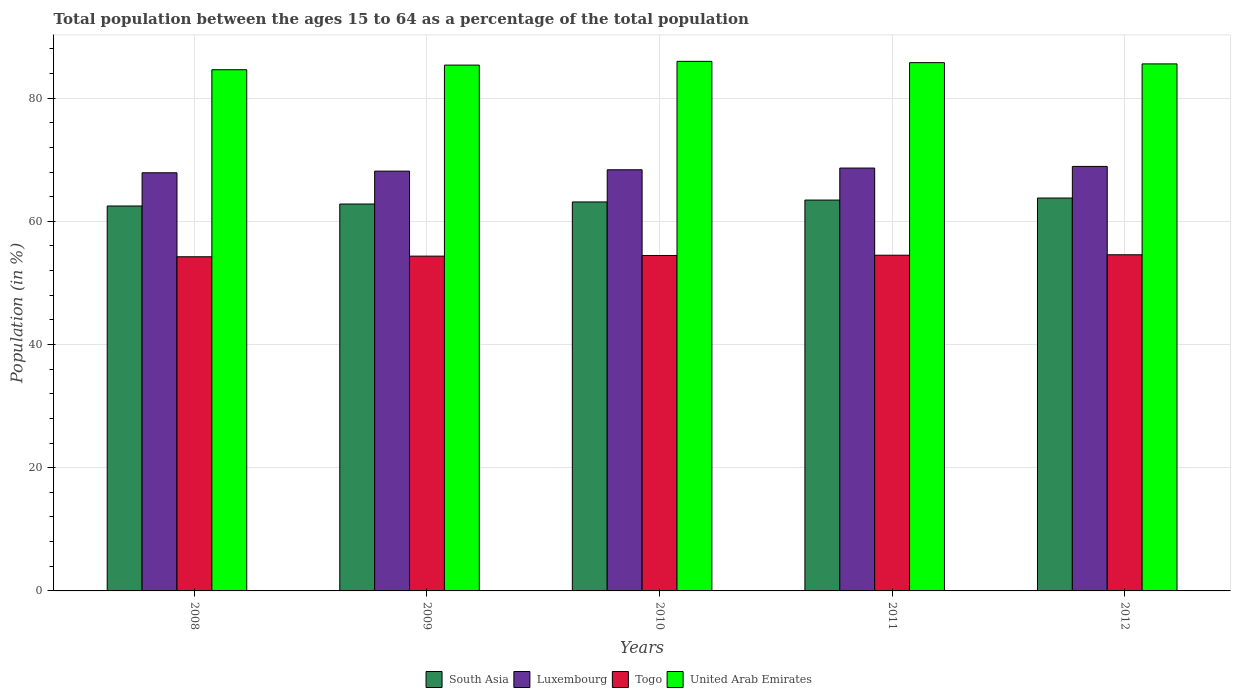Are the number of bars per tick equal to the number of legend labels?
Provide a succinct answer. Yes. How many bars are there on the 3rd tick from the left?
Your response must be concise. 4. How many bars are there on the 4th tick from the right?
Ensure brevity in your answer.  4. What is the label of the 3rd group of bars from the left?
Offer a terse response. 2010. What is the percentage of the population ages 15 to 64 in United Arab Emirates in 2008?
Offer a terse response. 84.6. Across all years, what is the maximum percentage of the population ages 15 to 64 in United Arab Emirates?
Your answer should be compact. 85.96. Across all years, what is the minimum percentage of the population ages 15 to 64 in Togo?
Make the answer very short. 54.24. What is the total percentage of the population ages 15 to 64 in Togo in the graph?
Your response must be concise. 272.1. What is the difference between the percentage of the population ages 15 to 64 in Togo in 2011 and that in 2012?
Your answer should be compact. -0.07. What is the difference between the percentage of the population ages 15 to 64 in South Asia in 2008 and the percentage of the population ages 15 to 64 in Luxembourg in 2009?
Make the answer very short. -5.66. What is the average percentage of the population ages 15 to 64 in Luxembourg per year?
Ensure brevity in your answer.  68.39. In the year 2010, what is the difference between the percentage of the population ages 15 to 64 in United Arab Emirates and percentage of the population ages 15 to 64 in South Asia?
Give a very brief answer. 22.82. In how many years, is the percentage of the population ages 15 to 64 in United Arab Emirates greater than 76?
Give a very brief answer. 5. What is the ratio of the percentage of the population ages 15 to 64 in Togo in 2008 to that in 2010?
Give a very brief answer. 1. Is the percentage of the population ages 15 to 64 in Luxembourg in 2008 less than that in 2010?
Provide a succinct answer. Yes. What is the difference between the highest and the second highest percentage of the population ages 15 to 64 in United Arab Emirates?
Offer a terse response. 0.21. What is the difference between the highest and the lowest percentage of the population ages 15 to 64 in United Arab Emirates?
Make the answer very short. 1.36. In how many years, is the percentage of the population ages 15 to 64 in South Asia greater than the average percentage of the population ages 15 to 64 in South Asia taken over all years?
Keep it short and to the point. 3. Is the sum of the percentage of the population ages 15 to 64 in South Asia in 2009 and 2010 greater than the maximum percentage of the population ages 15 to 64 in United Arab Emirates across all years?
Offer a very short reply. Yes. What does the 4th bar from the left in 2009 represents?
Ensure brevity in your answer.  United Arab Emirates. What does the 3rd bar from the right in 2009 represents?
Give a very brief answer. Luxembourg. How many bars are there?
Offer a very short reply. 20. What is the difference between two consecutive major ticks on the Y-axis?
Give a very brief answer. 20. Are the values on the major ticks of Y-axis written in scientific E-notation?
Provide a short and direct response. No. What is the title of the graph?
Provide a succinct answer. Total population between the ages 15 to 64 as a percentage of the total population. What is the Population (in %) in South Asia in 2008?
Your answer should be very brief. 62.49. What is the Population (in %) of Luxembourg in 2008?
Give a very brief answer. 67.88. What is the Population (in %) of Togo in 2008?
Make the answer very short. 54.24. What is the Population (in %) in United Arab Emirates in 2008?
Your response must be concise. 84.6. What is the Population (in %) of South Asia in 2009?
Give a very brief answer. 62.8. What is the Population (in %) of Luxembourg in 2009?
Make the answer very short. 68.14. What is the Population (in %) of Togo in 2009?
Keep it short and to the point. 54.34. What is the Population (in %) of United Arab Emirates in 2009?
Your answer should be compact. 85.35. What is the Population (in %) in South Asia in 2010?
Your answer should be very brief. 63.14. What is the Population (in %) of Luxembourg in 2010?
Make the answer very short. 68.36. What is the Population (in %) in Togo in 2010?
Your response must be concise. 54.45. What is the Population (in %) in United Arab Emirates in 2010?
Keep it short and to the point. 85.96. What is the Population (in %) of South Asia in 2011?
Your response must be concise. 63.45. What is the Population (in %) in Luxembourg in 2011?
Provide a short and direct response. 68.64. What is the Population (in %) in Togo in 2011?
Make the answer very short. 54.49. What is the Population (in %) of United Arab Emirates in 2011?
Your response must be concise. 85.75. What is the Population (in %) of South Asia in 2012?
Offer a very short reply. 63.78. What is the Population (in %) of Luxembourg in 2012?
Provide a short and direct response. 68.91. What is the Population (in %) in Togo in 2012?
Your answer should be compact. 54.57. What is the Population (in %) in United Arab Emirates in 2012?
Provide a succinct answer. 85.55. Across all years, what is the maximum Population (in %) in South Asia?
Make the answer very short. 63.78. Across all years, what is the maximum Population (in %) of Luxembourg?
Offer a very short reply. 68.91. Across all years, what is the maximum Population (in %) of Togo?
Offer a terse response. 54.57. Across all years, what is the maximum Population (in %) of United Arab Emirates?
Ensure brevity in your answer.  85.96. Across all years, what is the minimum Population (in %) in South Asia?
Your answer should be compact. 62.49. Across all years, what is the minimum Population (in %) in Luxembourg?
Offer a terse response. 67.88. Across all years, what is the minimum Population (in %) in Togo?
Make the answer very short. 54.24. Across all years, what is the minimum Population (in %) of United Arab Emirates?
Give a very brief answer. 84.6. What is the total Population (in %) of South Asia in the graph?
Provide a succinct answer. 315.65. What is the total Population (in %) in Luxembourg in the graph?
Your answer should be very brief. 341.93. What is the total Population (in %) of Togo in the graph?
Offer a very short reply. 272.1. What is the total Population (in %) of United Arab Emirates in the graph?
Provide a short and direct response. 427.22. What is the difference between the Population (in %) in South Asia in 2008 and that in 2009?
Ensure brevity in your answer.  -0.32. What is the difference between the Population (in %) of Luxembourg in 2008 and that in 2009?
Keep it short and to the point. -0.27. What is the difference between the Population (in %) in Togo in 2008 and that in 2009?
Keep it short and to the point. -0.1. What is the difference between the Population (in %) of United Arab Emirates in 2008 and that in 2009?
Provide a succinct answer. -0.75. What is the difference between the Population (in %) of South Asia in 2008 and that in 2010?
Offer a terse response. -0.66. What is the difference between the Population (in %) of Luxembourg in 2008 and that in 2010?
Offer a terse response. -0.49. What is the difference between the Population (in %) of Togo in 2008 and that in 2010?
Keep it short and to the point. -0.21. What is the difference between the Population (in %) in United Arab Emirates in 2008 and that in 2010?
Your response must be concise. -1.36. What is the difference between the Population (in %) of South Asia in 2008 and that in 2011?
Give a very brief answer. -0.96. What is the difference between the Population (in %) of Luxembourg in 2008 and that in 2011?
Keep it short and to the point. -0.76. What is the difference between the Population (in %) of Togo in 2008 and that in 2011?
Offer a terse response. -0.25. What is the difference between the Population (in %) of United Arab Emirates in 2008 and that in 2011?
Offer a very short reply. -1.15. What is the difference between the Population (in %) of South Asia in 2008 and that in 2012?
Your answer should be very brief. -1.29. What is the difference between the Population (in %) in Luxembourg in 2008 and that in 2012?
Keep it short and to the point. -1.03. What is the difference between the Population (in %) in Togo in 2008 and that in 2012?
Ensure brevity in your answer.  -0.32. What is the difference between the Population (in %) of United Arab Emirates in 2008 and that in 2012?
Your answer should be very brief. -0.95. What is the difference between the Population (in %) of South Asia in 2009 and that in 2010?
Provide a short and direct response. -0.34. What is the difference between the Population (in %) in Luxembourg in 2009 and that in 2010?
Your response must be concise. -0.22. What is the difference between the Population (in %) of Togo in 2009 and that in 2010?
Make the answer very short. -0.11. What is the difference between the Population (in %) in United Arab Emirates in 2009 and that in 2010?
Your answer should be compact. -0.61. What is the difference between the Population (in %) in South Asia in 2009 and that in 2011?
Keep it short and to the point. -0.64. What is the difference between the Population (in %) in Luxembourg in 2009 and that in 2011?
Offer a very short reply. -0.5. What is the difference between the Population (in %) in Togo in 2009 and that in 2011?
Your response must be concise. -0.15. What is the difference between the Population (in %) of United Arab Emirates in 2009 and that in 2011?
Provide a short and direct response. -0.4. What is the difference between the Population (in %) of South Asia in 2009 and that in 2012?
Your answer should be compact. -0.97. What is the difference between the Population (in %) in Luxembourg in 2009 and that in 2012?
Provide a succinct answer. -0.76. What is the difference between the Population (in %) in Togo in 2009 and that in 2012?
Keep it short and to the point. -0.22. What is the difference between the Population (in %) of United Arab Emirates in 2009 and that in 2012?
Provide a succinct answer. -0.2. What is the difference between the Population (in %) in South Asia in 2010 and that in 2011?
Your answer should be compact. -0.3. What is the difference between the Population (in %) in Luxembourg in 2010 and that in 2011?
Provide a succinct answer. -0.28. What is the difference between the Population (in %) of Togo in 2010 and that in 2011?
Keep it short and to the point. -0.04. What is the difference between the Population (in %) in United Arab Emirates in 2010 and that in 2011?
Ensure brevity in your answer.  0.21. What is the difference between the Population (in %) of South Asia in 2010 and that in 2012?
Provide a succinct answer. -0.64. What is the difference between the Population (in %) in Luxembourg in 2010 and that in 2012?
Your answer should be very brief. -0.54. What is the difference between the Population (in %) in Togo in 2010 and that in 2012?
Your answer should be compact. -0.11. What is the difference between the Population (in %) of United Arab Emirates in 2010 and that in 2012?
Provide a short and direct response. 0.41. What is the difference between the Population (in %) of South Asia in 2011 and that in 2012?
Your answer should be very brief. -0.33. What is the difference between the Population (in %) in Luxembourg in 2011 and that in 2012?
Make the answer very short. -0.26. What is the difference between the Population (in %) of Togo in 2011 and that in 2012?
Offer a terse response. -0.07. What is the difference between the Population (in %) of United Arab Emirates in 2011 and that in 2012?
Ensure brevity in your answer.  0.2. What is the difference between the Population (in %) in South Asia in 2008 and the Population (in %) in Luxembourg in 2009?
Ensure brevity in your answer.  -5.66. What is the difference between the Population (in %) of South Asia in 2008 and the Population (in %) of Togo in 2009?
Offer a very short reply. 8.14. What is the difference between the Population (in %) in South Asia in 2008 and the Population (in %) in United Arab Emirates in 2009?
Offer a very short reply. -22.87. What is the difference between the Population (in %) of Luxembourg in 2008 and the Population (in %) of Togo in 2009?
Your answer should be compact. 13.53. What is the difference between the Population (in %) in Luxembourg in 2008 and the Population (in %) in United Arab Emirates in 2009?
Give a very brief answer. -17.48. What is the difference between the Population (in %) in Togo in 2008 and the Population (in %) in United Arab Emirates in 2009?
Your response must be concise. -31.11. What is the difference between the Population (in %) in South Asia in 2008 and the Population (in %) in Luxembourg in 2010?
Your answer should be very brief. -5.88. What is the difference between the Population (in %) of South Asia in 2008 and the Population (in %) of Togo in 2010?
Offer a very short reply. 8.03. What is the difference between the Population (in %) in South Asia in 2008 and the Population (in %) in United Arab Emirates in 2010?
Your response must be concise. -23.48. What is the difference between the Population (in %) of Luxembourg in 2008 and the Population (in %) of Togo in 2010?
Give a very brief answer. 13.43. What is the difference between the Population (in %) of Luxembourg in 2008 and the Population (in %) of United Arab Emirates in 2010?
Ensure brevity in your answer.  -18.09. What is the difference between the Population (in %) in Togo in 2008 and the Population (in %) in United Arab Emirates in 2010?
Provide a succinct answer. -31.72. What is the difference between the Population (in %) in South Asia in 2008 and the Population (in %) in Luxembourg in 2011?
Your answer should be compact. -6.16. What is the difference between the Population (in %) of South Asia in 2008 and the Population (in %) of Togo in 2011?
Give a very brief answer. 7.99. What is the difference between the Population (in %) of South Asia in 2008 and the Population (in %) of United Arab Emirates in 2011?
Ensure brevity in your answer.  -23.27. What is the difference between the Population (in %) in Luxembourg in 2008 and the Population (in %) in Togo in 2011?
Offer a very short reply. 13.38. What is the difference between the Population (in %) of Luxembourg in 2008 and the Population (in %) of United Arab Emirates in 2011?
Provide a short and direct response. -17.88. What is the difference between the Population (in %) in Togo in 2008 and the Population (in %) in United Arab Emirates in 2011?
Your answer should be very brief. -31.51. What is the difference between the Population (in %) in South Asia in 2008 and the Population (in %) in Luxembourg in 2012?
Offer a terse response. -6.42. What is the difference between the Population (in %) of South Asia in 2008 and the Population (in %) of Togo in 2012?
Provide a short and direct response. 7.92. What is the difference between the Population (in %) in South Asia in 2008 and the Population (in %) in United Arab Emirates in 2012?
Offer a terse response. -23.06. What is the difference between the Population (in %) of Luxembourg in 2008 and the Population (in %) of Togo in 2012?
Give a very brief answer. 13.31. What is the difference between the Population (in %) of Luxembourg in 2008 and the Population (in %) of United Arab Emirates in 2012?
Give a very brief answer. -17.67. What is the difference between the Population (in %) in Togo in 2008 and the Population (in %) in United Arab Emirates in 2012?
Provide a short and direct response. -31.31. What is the difference between the Population (in %) in South Asia in 2009 and the Population (in %) in Luxembourg in 2010?
Provide a succinct answer. -5.56. What is the difference between the Population (in %) in South Asia in 2009 and the Population (in %) in Togo in 2010?
Offer a terse response. 8.35. What is the difference between the Population (in %) in South Asia in 2009 and the Population (in %) in United Arab Emirates in 2010?
Provide a succinct answer. -23.16. What is the difference between the Population (in %) of Luxembourg in 2009 and the Population (in %) of Togo in 2010?
Keep it short and to the point. 13.69. What is the difference between the Population (in %) of Luxembourg in 2009 and the Population (in %) of United Arab Emirates in 2010?
Keep it short and to the point. -17.82. What is the difference between the Population (in %) in Togo in 2009 and the Population (in %) in United Arab Emirates in 2010?
Your answer should be very brief. -31.62. What is the difference between the Population (in %) in South Asia in 2009 and the Population (in %) in Luxembourg in 2011?
Offer a very short reply. -5.84. What is the difference between the Population (in %) in South Asia in 2009 and the Population (in %) in Togo in 2011?
Your answer should be compact. 8.31. What is the difference between the Population (in %) of South Asia in 2009 and the Population (in %) of United Arab Emirates in 2011?
Offer a terse response. -22.95. What is the difference between the Population (in %) of Luxembourg in 2009 and the Population (in %) of Togo in 2011?
Your answer should be very brief. 13.65. What is the difference between the Population (in %) of Luxembourg in 2009 and the Population (in %) of United Arab Emirates in 2011?
Your answer should be very brief. -17.61. What is the difference between the Population (in %) in Togo in 2009 and the Population (in %) in United Arab Emirates in 2011?
Provide a short and direct response. -31.41. What is the difference between the Population (in %) in South Asia in 2009 and the Population (in %) in Luxembourg in 2012?
Keep it short and to the point. -6.1. What is the difference between the Population (in %) of South Asia in 2009 and the Population (in %) of Togo in 2012?
Ensure brevity in your answer.  8.24. What is the difference between the Population (in %) of South Asia in 2009 and the Population (in %) of United Arab Emirates in 2012?
Make the answer very short. -22.75. What is the difference between the Population (in %) of Luxembourg in 2009 and the Population (in %) of Togo in 2012?
Make the answer very short. 13.58. What is the difference between the Population (in %) of Luxembourg in 2009 and the Population (in %) of United Arab Emirates in 2012?
Give a very brief answer. -17.41. What is the difference between the Population (in %) of Togo in 2009 and the Population (in %) of United Arab Emirates in 2012?
Ensure brevity in your answer.  -31.21. What is the difference between the Population (in %) of South Asia in 2010 and the Population (in %) of Luxembourg in 2011?
Your response must be concise. -5.5. What is the difference between the Population (in %) in South Asia in 2010 and the Population (in %) in Togo in 2011?
Keep it short and to the point. 8.65. What is the difference between the Population (in %) in South Asia in 2010 and the Population (in %) in United Arab Emirates in 2011?
Offer a terse response. -22.61. What is the difference between the Population (in %) in Luxembourg in 2010 and the Population (in %) in Togo in 2011?
Your answer should be very brief. 13.87. What is the difference between the Population (in %) of Luxembourg in 2010 and the Population (in %) of United Arab Emirates in 2011?
Give a very brief answer. -17.39. What is the difference between the Population (in %) of Togo in 2010 and the Population (in %) of United Arab Emirates in 2011?
Provide a succinct answer. -31.3. What is the difference between the Population (in %) in South Asia in 2010 and the Population (in %) in Luxembourg in 2012?
Offer a terse response. -5.76. What is the difference between the Population (in %) in South Asia in 2010 and the Population (in %) in Togo in 2012?
Your response must be concise. 8.57. What is the difference between the Population (in %) in South Asia in 2010 and the Population (in %) in United Arab Emirates in 2012?
Give a very brief answer. -22.41. What is the difference between the Population (in %) in Luxembourg in 2010 and the Population (in %) in Togo in 2012?
Your response must be concise. 13.8. What is the difference between the Population (in %) in Luxembourg in 2010 and the Population (in %) in United Arab Emirates in 2012?
Provide a succinct answer. -17.19. What is the difference between the Population (in %) in Togo in 2010 and the Population (in %) in United Arab Emirates in 2012?
Make the answer very short. -31.1. What is the difference between the Population (in %) in South Asia in 2011 and the Population (in %) in Luxembourg in 2012?
Keep it short and to the point. -5.46. What is the difference between the Population (in %) of South Asia in 2011 and the Population (in %) of Togo in 2012?
Give a very brief answer. 8.88. What is the difference between the Population (in %) in South Asia in 2011 and the Population (in %) in United Arab Emirates in 2012?
Your answer should be very brief. -22.1. What is the difference between the Population (in %) in Luxembourg in 2011 and the Population (in %) in Togo in 2012?
Offer a terse response. 14.08. What is the difference between the Population (in %) in Luxembourg in 2011 and the Population (in %) in United Arab Emirates in 2012?
Your answer should be very brief. -16.91. What is the difference between the Population (in %) of Togo in 2011 and the Population (in %) of United Arab Emirates in 2012?
Your answer should be compact. -31.06. What is the average Population (in %) of South Asia per year?
Make the answer very short. 63.13. What is the average Population (in %) of Luxembourg per year?
Provide a succinct answer. 68.39. What is the average Population (in %) in Togo per year?
Keep it short and to the point. 54.42. What is the average Population (in %) of United Arab Emirates per year?
Your answer should be very brief. 85.44. In the year 2008, what is the difference between the Population (in %) in South Asia and Population (in %) in Luxembourg?
Your response must be concise. -5.39. In the year 2008, what is the difference between the Population (in %) in South Asia and Population (in %) in Togo?
Offer a terse response. 8.24. In the year 2008, what is the difference between the Population (in %) in South Asia and Population (in %) in United Arab Emirates?
Provide a short and direct response. -22.12. In the year 2008, what is the difference between the Population (in %) in Luxembourg and Population (in %) in Togo?
Ensure brevity in your answer.  13.63. In the year 2008, what is the difference between the Population (in %) of Luxembourg and Population (in %) of United Arab Emirates?
Offer a terse response. -16.72. In the year 2008, what is the difference between the Population (in %) in Togo and Population (in %) in United Arab Emirates?
Make the answer very short. -30.36. In the year 2009, what is the difference between the Population (in %) in South Asia and Population (in %) in Luxembourg?
Keep it short and to the point. -5.34. In the year 2009, what is the difference between the Population (in %) of South Asia and Population (in %) of Togo?
Your answer should be very brief. 8.46. In the year 2009, what is the difference between the Population (in %) of South Asia and Population (in %) of United Arab Emirates?
Your response must be concise. -22.55. In the year 2009, what is the difference between the Population (in %) of Luxembourg and Population (in %) of Togo?
Your answer should be very brief. 13.8. In the year 2009, what is the difference between the Population (in %) of Luxembourg and Population (in %) of United Arab Emirates?
Your answer should be compact. -17.21. In the year 2009, what is the difference between the Population (in %) of Togo and Population (in %) of United Arab Emirates?
Offer a very short reply. -31.01. In the year 2010, what is the difference between the Population (in %) in South Asia and Population (in %) in Luxembourg?
Your response must be concise. -5.22. In the year 2010, what is the difference between the Population (in %) of South Asia and Population (in %) of Togo?
Make the answer very short. 8.69. In the year 2010, what is the difference between the Population (in %) of South Asia and Population (in %) of United Arab Emirates?
Keep it short and to the point. -22.82. In the year 2010, what is the difference between the Population (in %) of Luxembourg and Population (in %) of Togo?
Give a very brief answer. 13.91. In the year 2010, what is the difference between the Population (in %) in Luxembourg and Population (in %) in United Arab Emirates?
Your answer should be compact. -17.6. In the year 2010, what is the difference between the Population (in %) in Togo and Population (in %) in United Arab Emirates?
Your answer should be very brief. -31.51. In the year 2011, what is the difference between the Population (in %) in South Asia and Population (in %) in Luxembourg?
Offer a terse response. -5.2. In the year 2011, what is the difference between the Population (in %) of South Asia and Population (in %) of Togo?
Keep it short and to the point. 8.95. In the year 2011, what is the difference between the Population (in %) of South Asia and Population (in %) of United Arab Emirates?
Provide a succinct answer. -22.31. In the year 2011, what is the difference between the Population (in %) of Luxembourg and Population (in %) of Togo?
Make the answer very short. 14.15. In the year 2011, what is the difference between the Population (in %) in Luxembourg and Population (in %) in United Arab Emirates?
Your response must be concise. -17.11. In the year 2011, what is the difference between the Population (in %) in Togo and Population (in %) in United Arab Emirates?
Offer a very short reply. -31.26. In the year 2012, what is the difference between the Population (in %) in South Asia and Population (in %) in Luxembourg?
Provide a succinct answer. -5.13. In the year 2012, what is the difference between the Population (in %) in South Asia and Population (in %) in Togo?
Keep it short and to the point. 9.21. In the year 2012, what is the difference between the Population (in %) in South Asia and Population (in %) in United Arab Emirates?
Make the answer very short. -21.77. In the year 2012, what is the difference between the Population (in %) in Luxembourg and Population (in %) in Togo?
Your response must be concise. 14.34. In the year 2012, what is the difference between the Population (in %) in Luxembourg and Population (in %) in United Arab Emirates?
Make the answer very short. -16.64. In the year 2012, what is the difference between the Population (in %) of Togo and Population (in %) of United Arab Emirates?
Your answer should be very brief. -30.98. What is the ratio of the Population (in %) in South Asia in 2008 to that in 2009?
Offer a terse response. 0.99. What is the ratio of the Population (in %) of Luxembourg in 2008 to that in 2009?
Your response must be concise. 1. What is the ratio of the Population (in %) in Togo in 2008 to that in 2009?
Your answer should be very brief. 1. What is the ratio of the Population (in %) in South Asia in 2008 to that in 2010?
Offer a terse response. 0.99. What is the ratio of the Population (in %) of Luxembourg in 2008 to that in 2010?
Offer a very short reply. 0.99. What is the ratio of the Population (in %) in Togo in 2008 to that in 2010?
Provide a succinct answer. 1. What is the ratio of the Population (in %) of United Arab Emirates in 2008 to that in 2010?
Your answer should be very brief. 0.98. What is the ratio of the Population (in %) of South Asia in 2008 to that in 2011?
Ensure brevity in your answer.  0.98. What is the ratio of the Population (in %) in Luxembourg in 2008 to that in 2011?
Offer a very short reply. 0.99. What is the ratio of the Population (in %) of United Arab Emirates in 2008 to that in 2011?
Provide a succinct answer. 0.99. What is the ratio of the Population (in %) of South Asia in 2008 to that in 2012?
Provide a short and direct response. 0.98. What is the ratio of the Population (in %) in Luxembourg in 2008 to that in 2012?
Provide a succinct answer. 0.99. What is the ratio of the Population (in %) of United Arab Emirates in 2008 to that in 2012?
Offer a very short reply. 0.99. What is the ratio of the Population (in %) of South Asia in 2009 to that in 2010?
Keep it short and to the point. 0.99. What is the ratio of the Population (in %) of Luxembourg in 2009 to that in 2010?
Give a very brief answer. 1. What is the ratio of the Population (in %) in Luxembourg in 2009 to that in 2011?
Offer a very short reply. 0.99. What is the ratio of the Population (in %) in Togo in 2009 to that in 2011?
Ensure brevity in your answer.  1. What is the ratio of the Population (in %) in South Asia in 2009 to that in 2012?
Your answer should be very brief. 0.98. What is the ratio of the Population (in %) of Luxembourg in 2009 to that in 2012?
Provide a succinct answer. 0.99. What is the ratio of the Population (in %) in United Arab Emirates in 2009 to that in 2012?
Give a very brief answer. 1. What is the ratio of the Population (in %) of South Asia in 2010 to that in 2011?
Ensure brevity in your answer.  1. What is the ratio of the Population (in %) of United Arab Emirates in 2010 to that in 2011?
Your response must be concise. 1. What is the ratio of the Population (in %) in South Asia in 2010 to that in 2012?
Your answer should be very brief. 0.99. What is the ratio of the Population (in %) of Luxembourg in 2010 to that in 2012?
Offer a terse response. 0.99. What is the ratio of the Population (in %) of United Arab Emirates in 2010 to that in 2012?
Your answer should be very brief. 1. What is the ratio of the Population (in %) in Luxembourg in 2011 to that in 2012?
Your answer should be compact. 1. What is the ratio of the Population (in %) in United Arab Emirates in 2011 to that in 2012?
Offer a terse response. 1. What is the difference between the highest and the second highest Population (in %) in South Asia?
Provide a succinct answer. 0.33. What is the difference between the highest and the second highest Population (in %) of Luxembourg?
Your answer should be compact. 0.26. What is the difference between the highest and the second highest Population (in %) of Togo?
Your answer should be very brief. 0.07. What is the difference between the highest and the second highest Population (in %) in United Arab Emirates?
Your response must be concise. 0.21. What is the difference between the highest and the lowest Population (in %) of South Asia?
Ensure brevity in your answer.  1.29. What is the difference between the highest and the lowest Population (in %) in Luxembourg?
Your answer should be very brief. 1.03. What is the difference between the highest and the lowest Population (in %) in Togo?
Offer a terse response. 0.32. What is the difference between the highest and the lowest Population (in %) of United Arab Emirates?
Offer a very short reply. 1.36. 